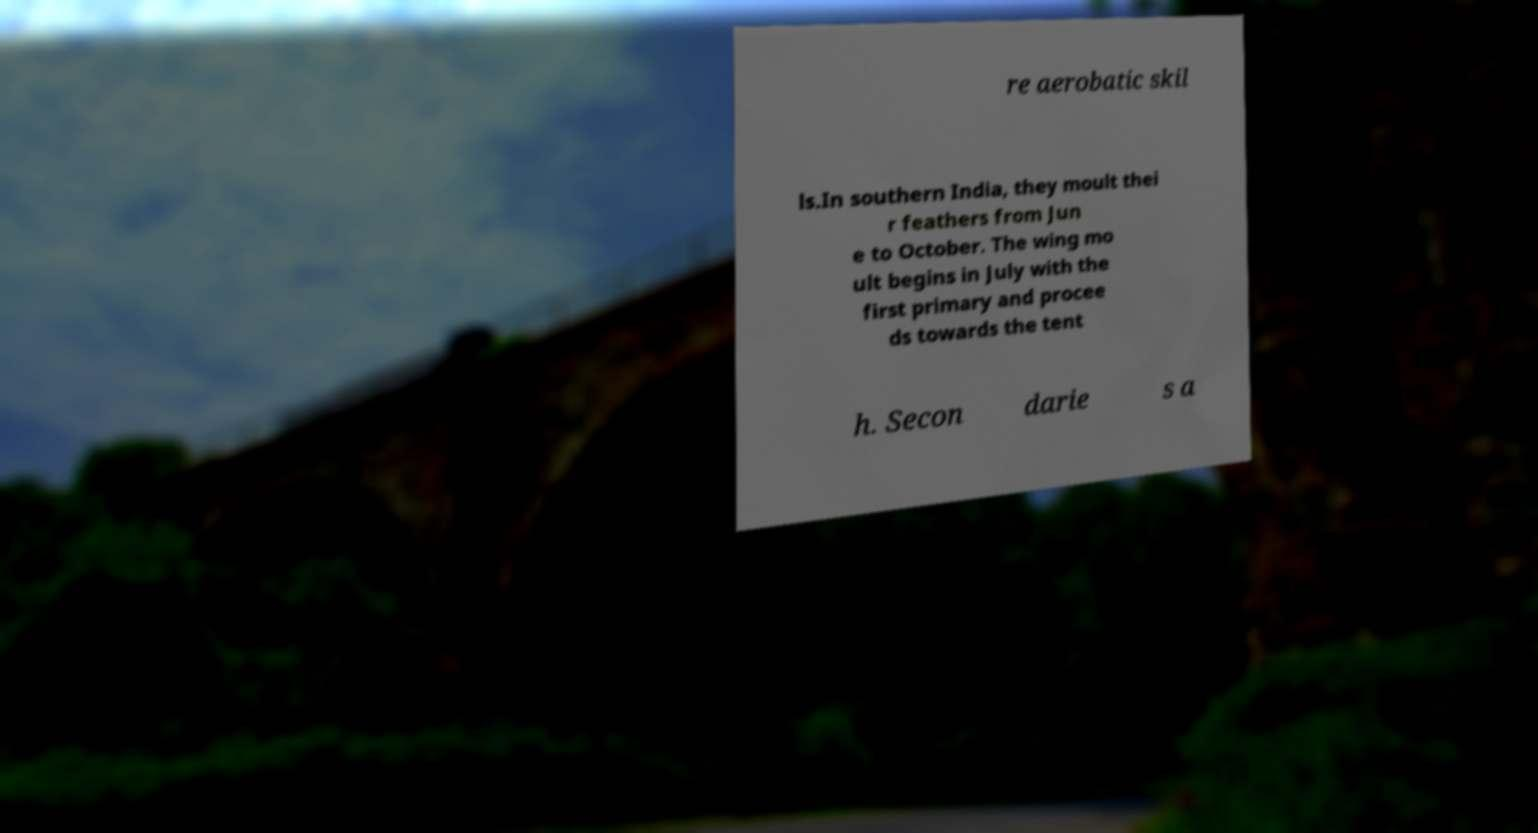There's text embedded in this image that I need extracted. Can you transcribe it verbatim? re aerobatic skil ls.In southern India, they moult thei r feathers from Jun e to October. The wing mo ult begins in July with the first primary and procee ds towards the tent h. Secon darie s a 